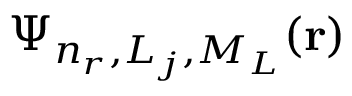<formula> <loc_0><loc_0><loc_500><loc_500>\Psi _ { n _ { r } , L _ { j } , M _ { L } } ( r )</formula> 